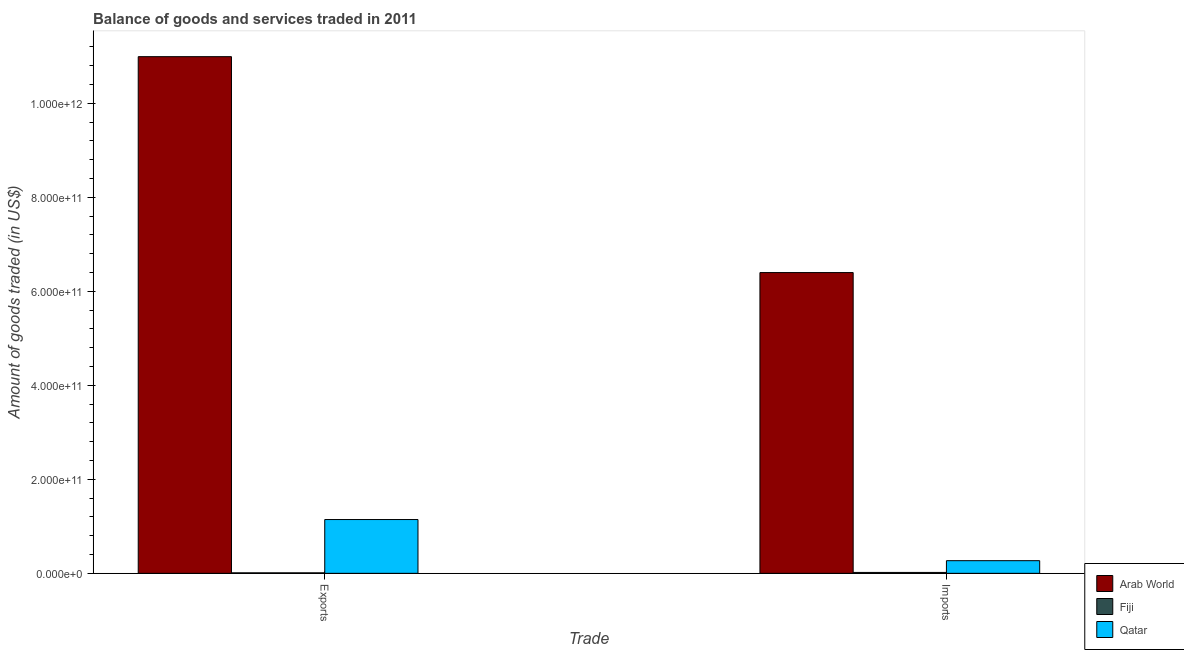How many different coloured bars are there?
Give a very brief answer. 3. Are the number of bars per tick equal to the number of legend labels?
Your answer should be compact. Yes. Are the number of bars on each tick of the X-axis equal?
Provide a succinct answer. Yes. How many bars are there on the 1st tick from the right?
Your response must be concise. 3. What is the label of the 2nd group of bars from the left?
Provide a succinct answer. Imports. What is the amount of goods exported in Fiji?
Make the answer very short. 1.06e+09. Across all countries, what is the maximum amount of goods imported?
Offer a terse response. 6.40e+11. Across all countries, what is the minimum amount of goods imported?
Provide a short and direct response. 1.91e+09. In which country was the amount of goods imported maximum?
Your answer should be compact. Arab World. In which country was the amount of goods imported minimum?
Offer a very short reply. Fiji. What is the total amount of goods imported in the graph?
Your answer should be compact. 6.69e+11. What is the difference between the amount of goods imported in Arab World and that in Fiji?
Give a very brief answer. 6.38e+11. What is the difference between the amount of goods imported in Fiji and the amount of goods exported in Qatar?
Offer a terse response. -1.13e+11. What is the average amount of goods imported per country?
Your answer should be very brief. 2.23e+11. What is the difference between the amount of goods imported and amount of goods exported in Arab World?
Offer a terse response. -4.59e+11. In how many countries, is the amount of goods imported greater than 880000000000 US$?
Make the answer very short. 0. What is the ratio of the amount of goods imported in Fiji to that in Qatar?
Your answer should be compact. 0.07. In how many countries, is the amount of goods imported greater than the average amount of goods imported taken over all countries?
Your answer should be very brief. 1. What does the 3rd bar from the left in Imports represents?
Ensure brevity in your answer.  Qatar. What does the 2nd bar from the right in Imports represents?
Provide a succinct answer. Fiji. How many bars are there?
Your answer should be compact. 6. What is the difference between two consecutive major ticks on the Y-axis?
Give a very brief answer. 2.00e+11. Does the graph contain grids?
Offer a very short reply. No. How many legend labels are there?
Provide a short and direct response. 3. What is the title of the graph?
Your answer should be compact. Balance of goods and services traded in 2011. Does "Bolivia" appear as one of the legend labels in the graph?
Make the answer very short. No. What is the label or title of the X-axis?
Your answer should be compact. Trade. What is the label or title of the Y-axis?
Offer a terse response. Amount of goods traded (in US$). What is the Amount of goods traded (in US$) in Arab World in Exports?
Ensure brevity in your answer.  1.10e+12. What is the Amount of goods traded (in US$) of Fiji in Exports?
Your response must be concise. 1.06e+09. What is the Amount of goods traded (in US$) in Qatar in Exports?
Offer a very short reply. 1.14e+11. What is the Amount of goods traded (in US$) of Arab World in Imports?
Ensure brevity in your answer.  6.40e+11. What is the Amount of goods traded (in US$) in Fiji in Imports?
Keep it short and to the point. 1.91e+09. What is the Amount of goods traded (in US$) in Qatar in Imports?
Make the answer very short. 2.69e+1. Across all Trade, what is the maximum Amount of goods traded (in US$) in Arab World?
Your response must be concise. 1.10e+12. Across all Trade, what is the maximum Amount of goods traded (in US$) of Fiji?
Provide a short and direct response. 1.91e+09. Across all Trade, what is the maximum Amount of goods traded (in US$) of Qatar?
Your answer should be compact. 1.14e+11. Across all Trade, what is the minimum Amount of goods traded (in US$) in Arab World?
Keep it short and to the point. 6.40e+11. Across all Trade, what is the minimum Amount of goods traded (in US$) of Fiji?
Offer a very short reply. 1.06e+09. Across all Trade, what is the minimum Amount of goods traded (in US$) of Qatar?
Offer a very short reply. 2.69e+1. What is the total Amount of goods traded (in US$) in Arab World in the graph?
Keep it short and to the point. 1.74e+12. What is the total Amount of goods traded (in US$) in Fiji in the graph?
Your response must be concise. 2.98e+09. What is the total Amount of goods traded (in US$) of Qatar in the graph?
Your answer should be very brief. 1.41e+11. What is the difference between the Amount of goods traded (in US$) of Arab World in Exports and that in Imports?
Offer a very short reply. 4.59e+11. What is the difference between the Amount of goods traded (in US$) of Fiji in Exports and that in Imports?
Offer a very short reply. -8.50e+08. What is the difference between the Amount of goods traded (in US$) in Qatar in Exports and that in Imports?
Provide a short and direct response. 8.75e+1. What is the difference between the Amount of goods traded (in US$) of Arab World in Exports and the Amount of goods traded (in US$) of Fiji in Imports?
Provide a short and direct response. 1.10e+12. What is the difference between the Amount of goods traded (in US$) of Arab World in Exports and the Amount of goods traded (in US$) of Qatar in Imports?
Your answer should be very brief. 1.07e+12. What is the difference between the Amount of goods traded (in US$) of Fiji in Exports and the Amount of goods traded (in US$) of Qatar in Imports?
Your answer should be compact. -2.59e+1. What is the average Amount of goods traded (in US$) in Arab World per Trade?
Provide a succinct answer. 8.70e+11. What is the average Amount of goods traded (in US$) in Fiji per Trade?
Provide a succinct answer. 1.49e+09. What is the average Amount of goods traded (in US$) in Qatar per Trade?
Give a very brief answer. 7.07e+1. What is the difference between the Amount of goods traded (in US$) in Arab World and Amount of goods traded (in US$) in Fiji in Exports?
Your response must be concise. 1.10e+12. What is the difference between the Amount of goods traded (in US$) in Arab World and Amount of goods traded (in US$) in Qatar in Exports?
Your answer should be very brief. 9.85e+11. What is the difference between the Amount of goods traded (in US$) of Fiji and Amount of goods traded (in US$) of Qatar in Exports?
Offer a terse response. -1.13e+11. What is the difference between the Amount of goods traded (in US$) of Arab World and Amount of goods traded (in US$) of Fiji in Imports?
Provide a succinct answer. 6.38e+11. What is the difference between the Amount of goods traded (in US$) in Arab World and Amount of goods traded (in US$) in Qatar in Imports?
Ensure brevity in your answer.  6.13e+11. What is the difference between the Amount of goods traded (in US$) of Fiji and Amount of goods traded (in US$) of Qatar in Imports?
Keep it short and to the point. -2.50e+1. What is the ratio of the Amount of goods traded (in US$) in Arab World in Exports to that in Imports?
Offer a very short reply. 1.72. What is the ratio of the Amount of goods traded (in US$) of Fiji in Exports to that in Imports?
Give a very brief answer. 0.56. What is the ratio of the Amount of goods traded (in US$) in Qatar in Exports to that in Imports?
Make the answer very short. 4.25. What is the difference between the highest and the second highest Amount of goods traded (in US$) in Arab World?
Provide a short and direct response. 4.59e+11. What is the difference between the highest and the second highest Amount of goods traded (in US$) in Fiji?
Your answer should be very brief. 8.50e+08. What is the difference between the highest and the second highest Amount of goods traded (in US$) in Qatar?
Your answer should be very brief. 8.75e+1. What is the difference between the highest and the lowest Amount of goods traded (in US$) of Arab World?
Your response must be concise. 4.59e+11. What is the difference between the highest and the lowest Amount of goods traded (in US$) in Fiji?
Make the answer very short. 8.50e+08. What is the difference between the highest and the lowest Amount of goods traded (in US$) in Qatar?
Keep it short and to the point. 8.75e+1. 